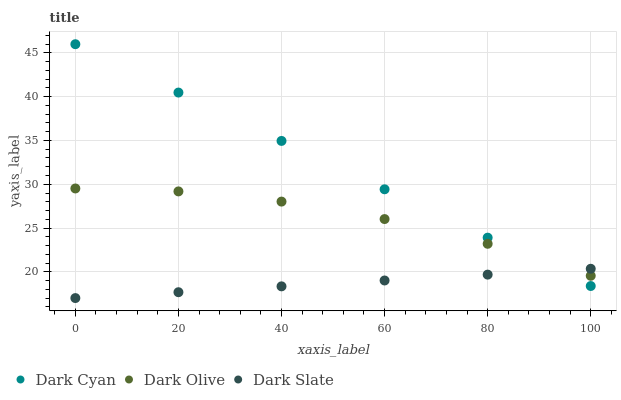Does Dark Slate have the minimum area under the curve?
Answer yes or no. Yes. Does Dark Cyan have the maximum area under the curve?
Answer yes or no. Yes. Does Dark Olive have the minimum area under the curve?
Answer yes or no. No. Does Dark Olive have the maximum area under the curve?
Answer yes or no. No. Is Dark Slate the smoothest?
Answer yes or no. Yes. Is Dark Olive the roughest?
Answer yes or no. Yes. Is Dark Olive the smoothest?
Answer yes or no. No. Is Dark Slate the roughest?
Answer yes or no. No. Does Dark Slate have the lowest value?
Answer yes or no. Yes. Does Dark Olive have the lowest value?
Answer yes or no. No. Does Dark Cyan have the highest value?
Answer yes or no. Yes. Does Dark Olive have the highest value?
Answer yes or no. No. Does Dark Cyan intersect Dark Olive?
Answer yes or no. Yes. Is Dark Cyan less than Dark Olive?
Answer yes or no. No. Is Dark Cyan greater than Dark Olive?
Answer yes or no. No. 